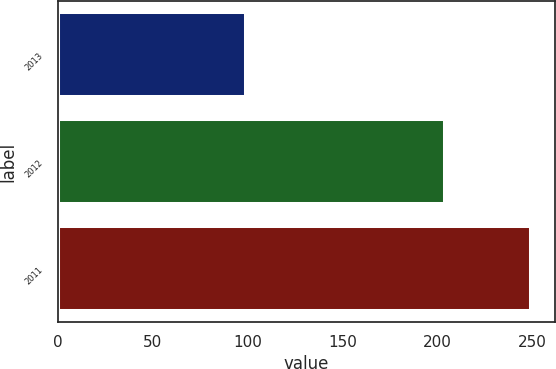Convert chart to OTSL. <chart><loc_0><loc_0><loc_500><loc_500><bar_chart><fcel>2013<fcel>2012<fcel>2011<nl><fcel>99<fcel>204<fcel>249<nl></chart> 